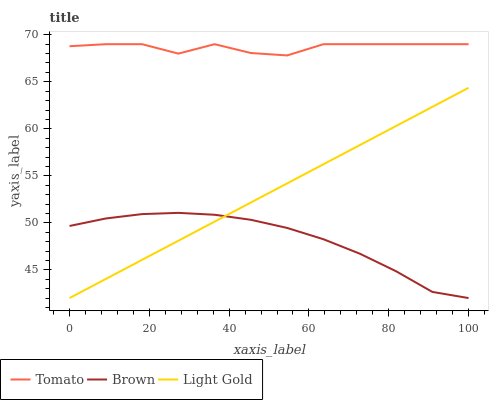Does Brown have the minimum area under the curve?
Answer yes or no. Yes. Does Tomato have the maximum area under the curve?
Answer yes or no. Yes. Does Light Gold have the minimum area under the curve?
Answer yes or no. No. Does Light Gold have the maximum area under the curve?
Answer yes or no. No. Is Light Gold the smoothest?
Answer yes or no. Yes. Is Tomato the roughest?
Answer yes or no. Yes. Is Brown the smoothest?
Answer yes or no. No. Is Brown the roughest?
Answer yes or no. No. Does Brown have the lowest value?
Answer yes or no. Yes. Does Tomato have the highest value?
Answer yes or no. Yes. Does Light Gold have the highest value?
Answer yes or no. No. Is Brown less than Tomato?
Answer yes or no. Yes. Is Tomato greater than Light Gold?
Answer yes or no. Yes. Does Brown intersect Light Gold?
Answer yes or no. Yes. Is Brown less than Light Gold?
Answer yes or no. No. Is Brown greater than Light Gold?
Answer yes or no. No. Does Brown intersect Tomato?
Answer yes or no. No. 